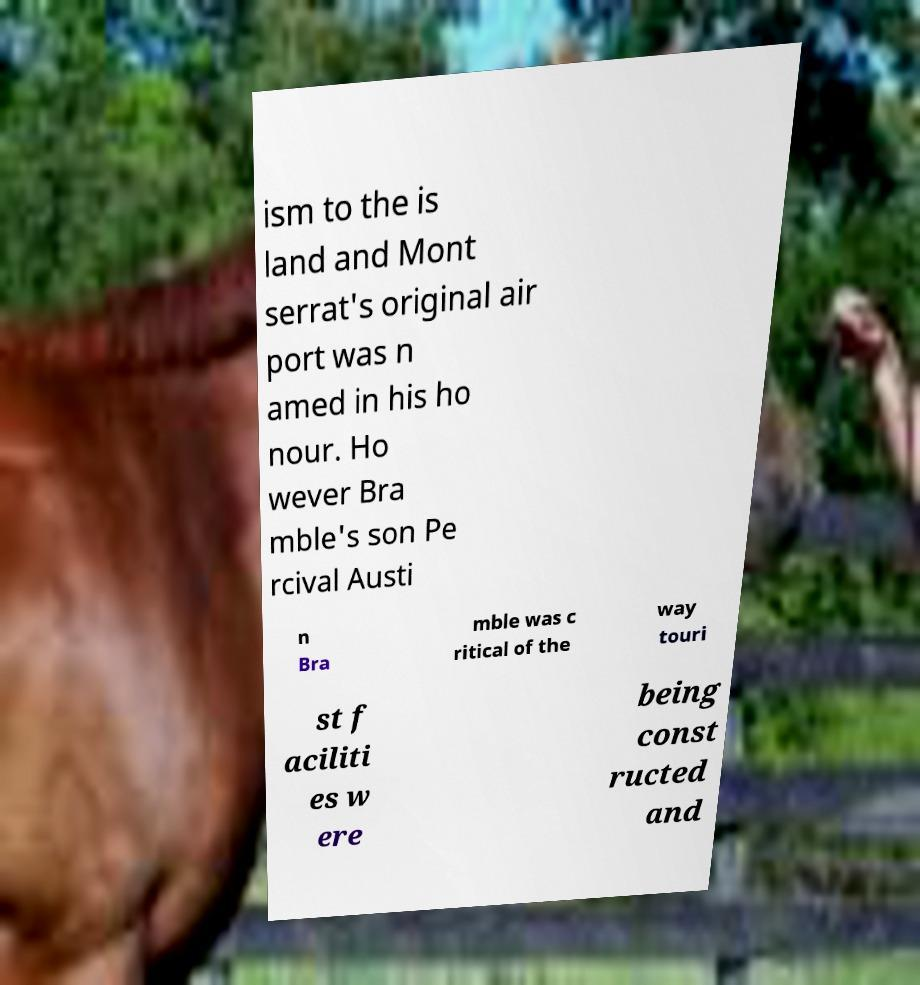Can you read and provide the text displayed in the image?This photo seems to have some interesting text. Can you extract and type it out for me? ism to the is land and Mont serrat's original air port was n amed in his ho nour. Ho wever Bra mble's son Pe rcival Austi n Bra mble was c ritical of the way touri st f aciliti es w ere being const ructed and 